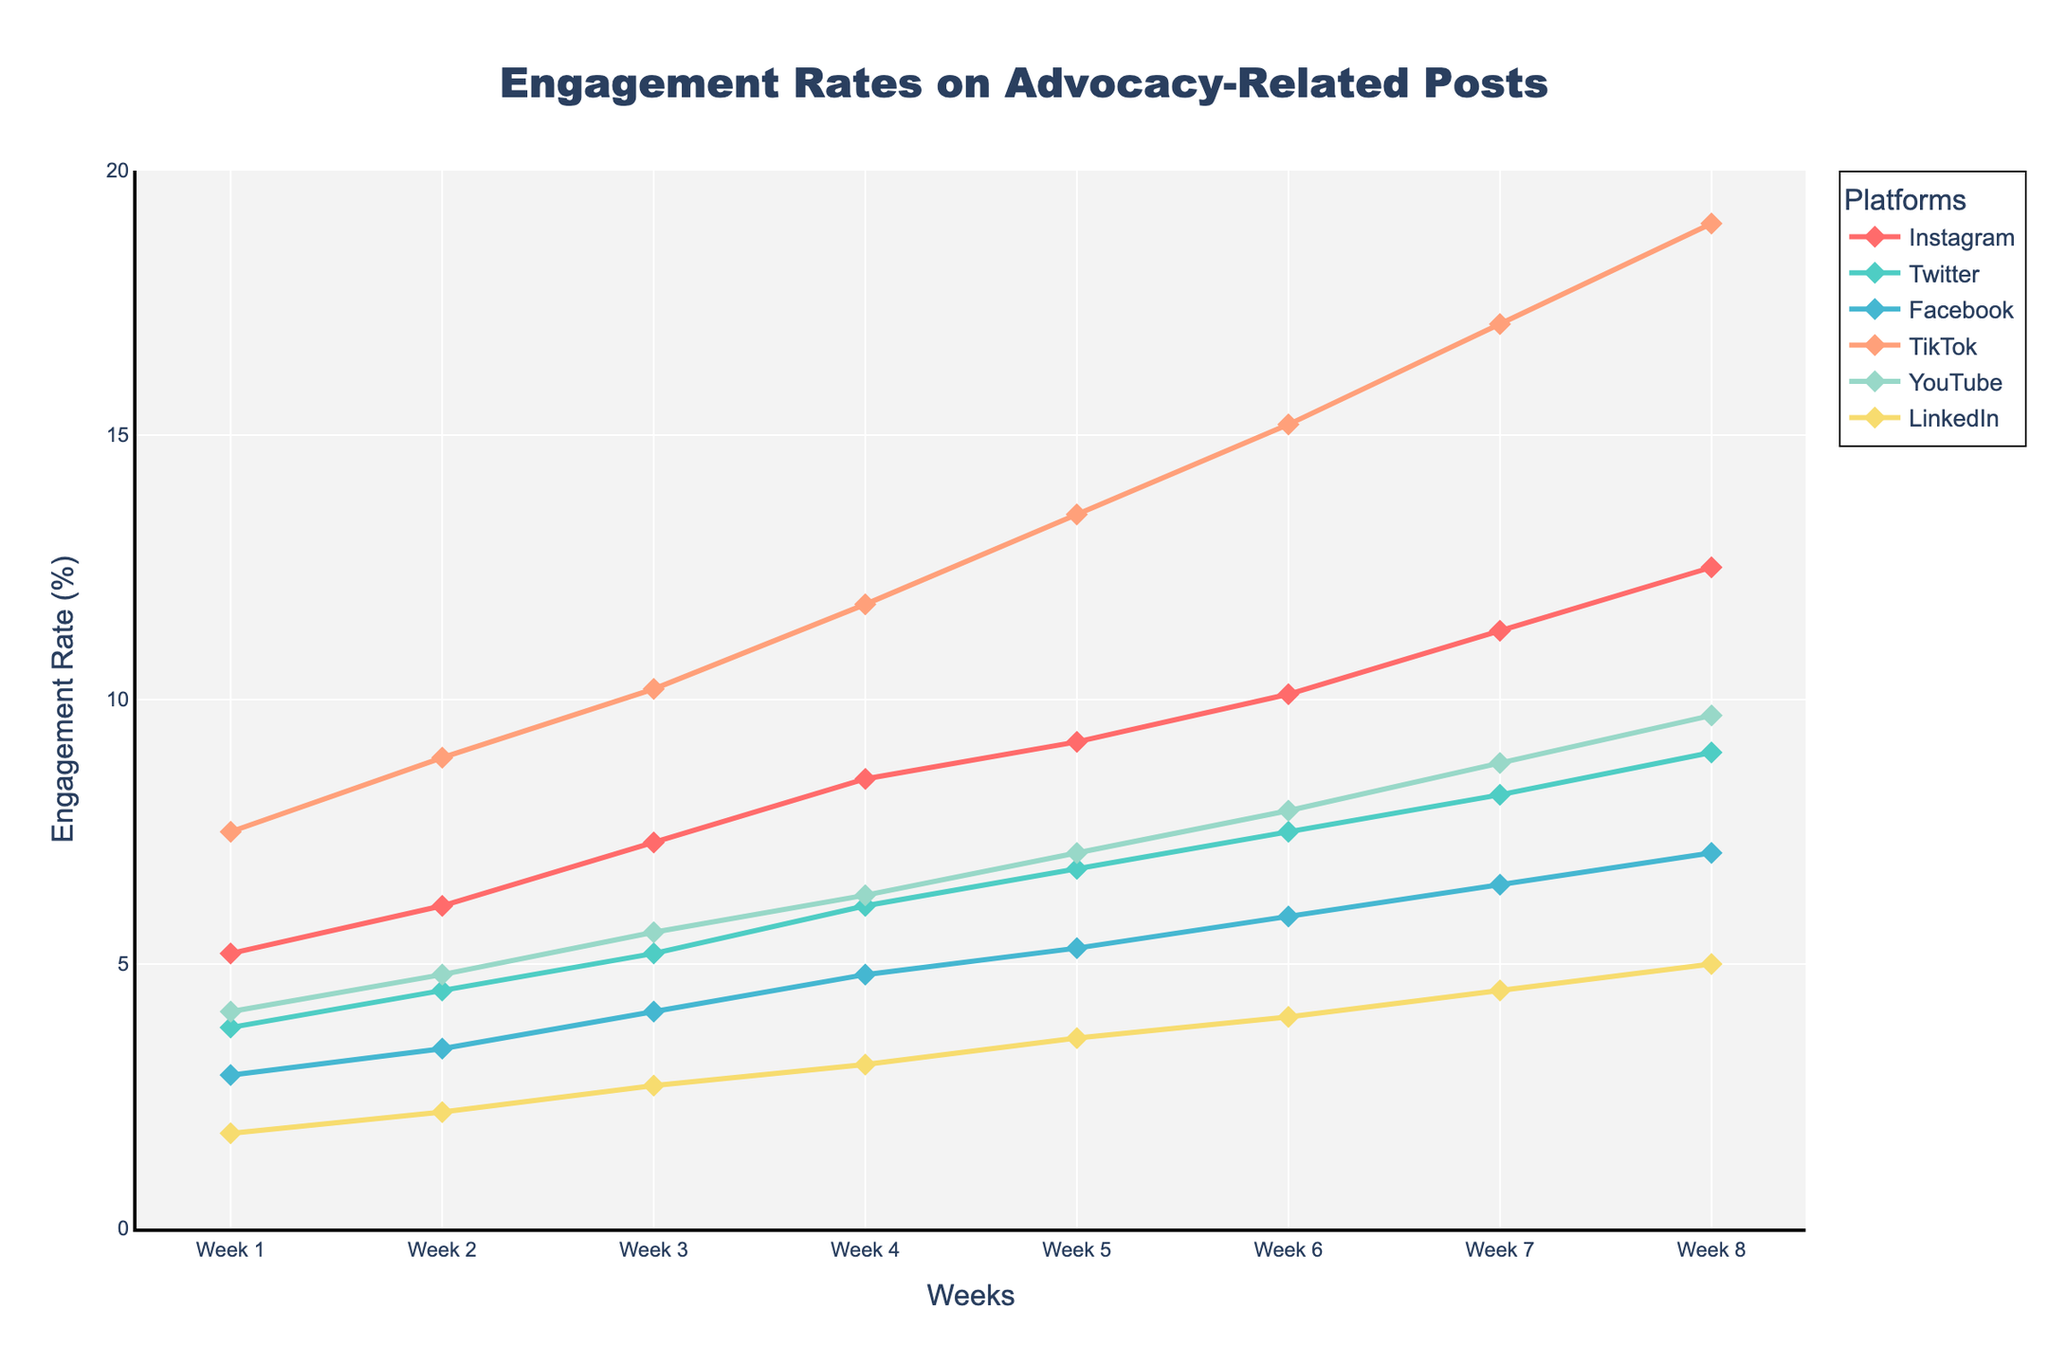Which platform had the highest engagement rate by Week 8? By Week 8, look at the end points of the lines on the plot. The line for TikTok ends at the highest point, at 19.0%.
Answer: TikTok Which platform had the lowest engagement rate in Week 1? To find this, check the starting points of the lines on the plot. The line for LinkedIn starts at the lowest point, at 1.8%.
Answer: LinkedIn Between which weeks did Instagram see the largest increase in engagement rate? Compare the differences in engagement rate between consecutive weeks for Instagram. The largest increase occurs between Week 7 (11.3%) and Week 8 (12.5%), an increase of 1.2%.
Answer: Between Week 7 and Week 8 How did the engagement rates for Twitter and Facebook compare over the 8 weeks? Throughout the 8 weeks, Twitter's engagement rate line is consistently above Facebook's engagement rate line. Twitter starts at 3.8% and ends at 9.0%, while Facebook starts at 2.9% and ends at 7.1%.
Answer: Twitter had higher engagement than Facebook By how much did TikTok's engagement rate increase from Week 1 to Week 8? Subtract the engagement rate of Week 1 from that of Week 8 for TikTok: 19.0% - 7.5% = 11.5%.
Answer: 11.5% Which platform had a consistent engagement rate increase every week? Inspect the lines on the plot for a consistent upward trend every week. TikTok, Instagram, Twitter, Facebook, YouTube, and LinkedIn all show a consistent increase each week.
Answer: All platforms What is the average engagement rate for LinkedIn over the 8 weeks? Add LinkedIn's engagement rates over 8 weeks (1.8 + 2.2 + 2.7 + 3.1 + 3.6 + 4.0 + 4.5 + 5.0) and divide by 8. The sum is 26.9; divide by 8 to get the average, 26.9 / 8 = 3.3625%.
Answer: 3.36% Which week did YouTube's engagement rate surpass Facebook's engagement rate? Compare YouTube and Facebook engagement rates for each week. YouTube surpasses Facebook at Week 7; YouTube at 8.8% is greater than Facebook at 6.5%.
Answer: Week 7 How much did Facebook's engagement rate grow from Week 4 to Week 8? Subtract Week 4's engagement rate from Week 8's for Facebook: 7.1% - 4.8% = 2.3%.
Answer: 2.3% Which platform showed the smallest increase in engagement rate from Week 1 to Week 8? Calculate the total increase for each platform. LinkedIn has the smallest increase: 5.0% - 1.8% = 3.2%.
Answer: LinkedIn 